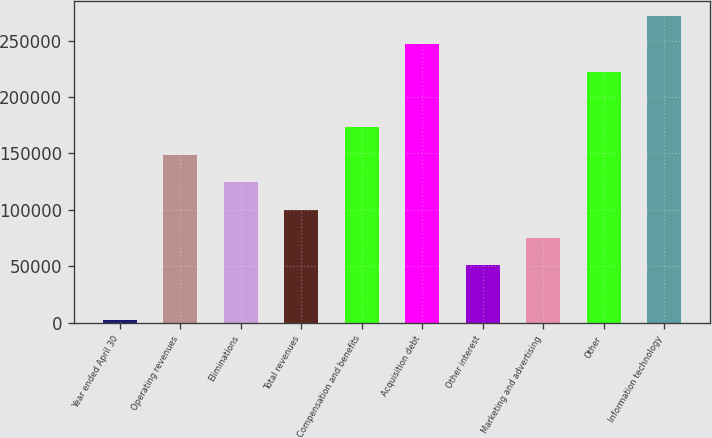Convert chart to OTSL. <chart><loc_0><loc_0><loc_500><loc_500><bar_chart><fcel>Year ended April 30<fcel>Operating revenues<fcel>Eliminations<fcel>Total revenues<fcel>Compensation and benefits<fcel>Acquisition debt<fcel>Other interest<fcel>Marketing and advertising<fcel>Other<fcel>Information technology<nl><fcel>2002<fcel>149064<fcel>124554<fcel>100044<fcel>173575<fcel>247106<fcel>51022.8<fcel>75533.2<fcel>222596<fcel>271616<nl></chart> 